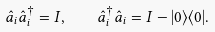Convert formula to latex. <formula><loc_0><loc_0><loc_500><loc_500>\hat { a } _ { i } \hat { a } _ { i } ^ { \dagger } = I , \quad \hat { a } ^ { \dagger } _ { i } \hat { a } _ { i } = I - | 0 \rangle \langle 0 | .</formula> 